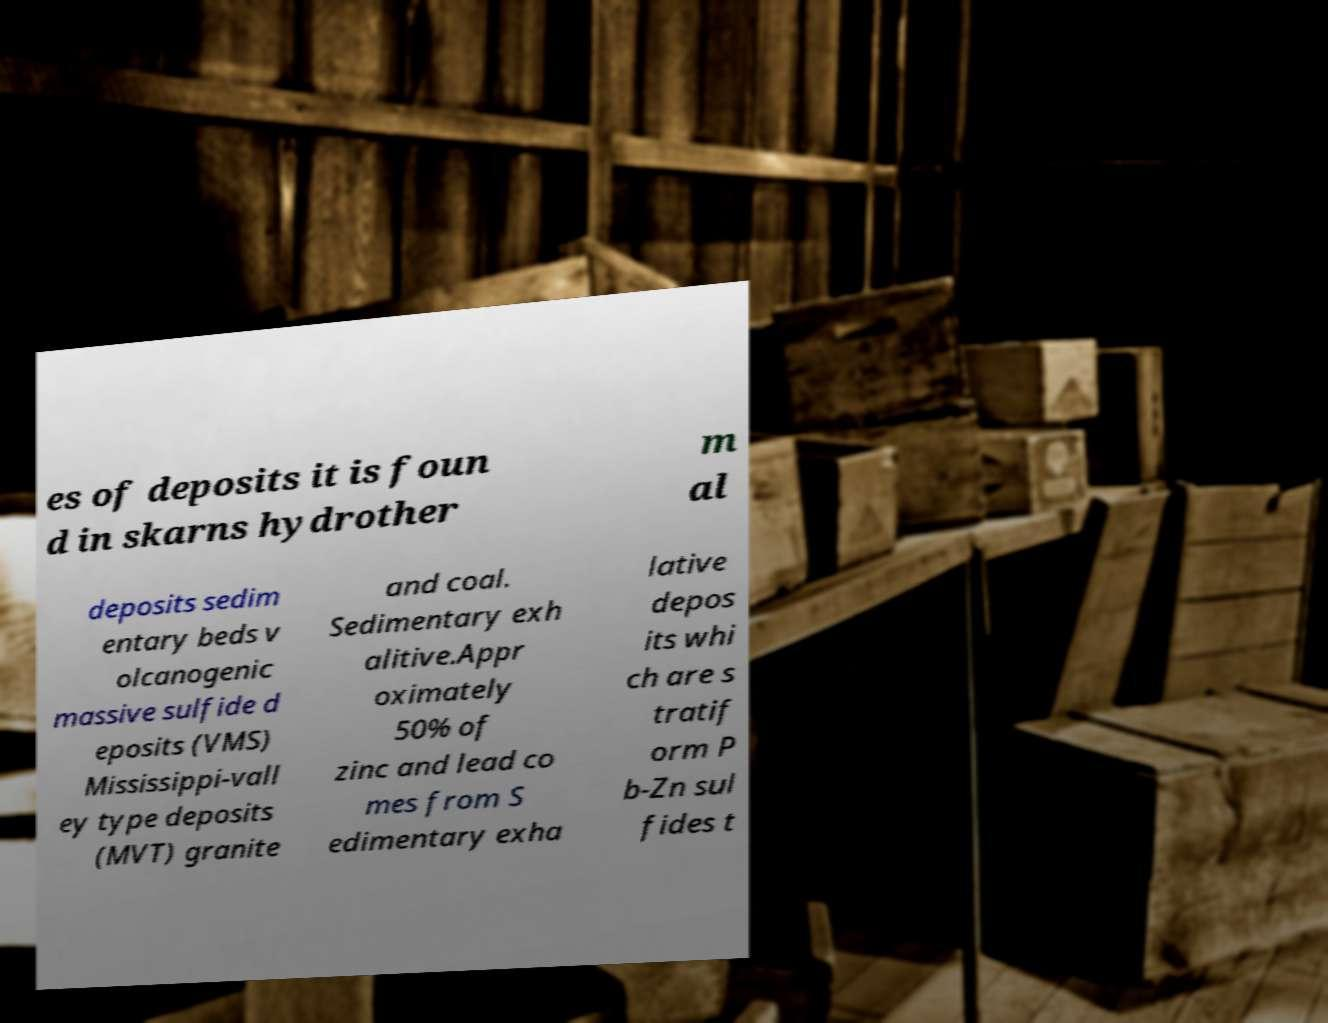Can you read and provide the text displayed in the image?This photo seems to have some interesting text. Can you extract and type it out for me? es of deposits it is foun d in skarns hydrother m al deposits sedim entary beds v olcanogenic massive sulfide d eposits (VMS) Mississippi-vall ey type deposits (MVT) granite and coal. Sedimentary exh alitive.Appr oximately 50% of zinc and lead co mes from S edimentary exha lative depos its whi ch are s tratif orm P b-Zn sul fides t 